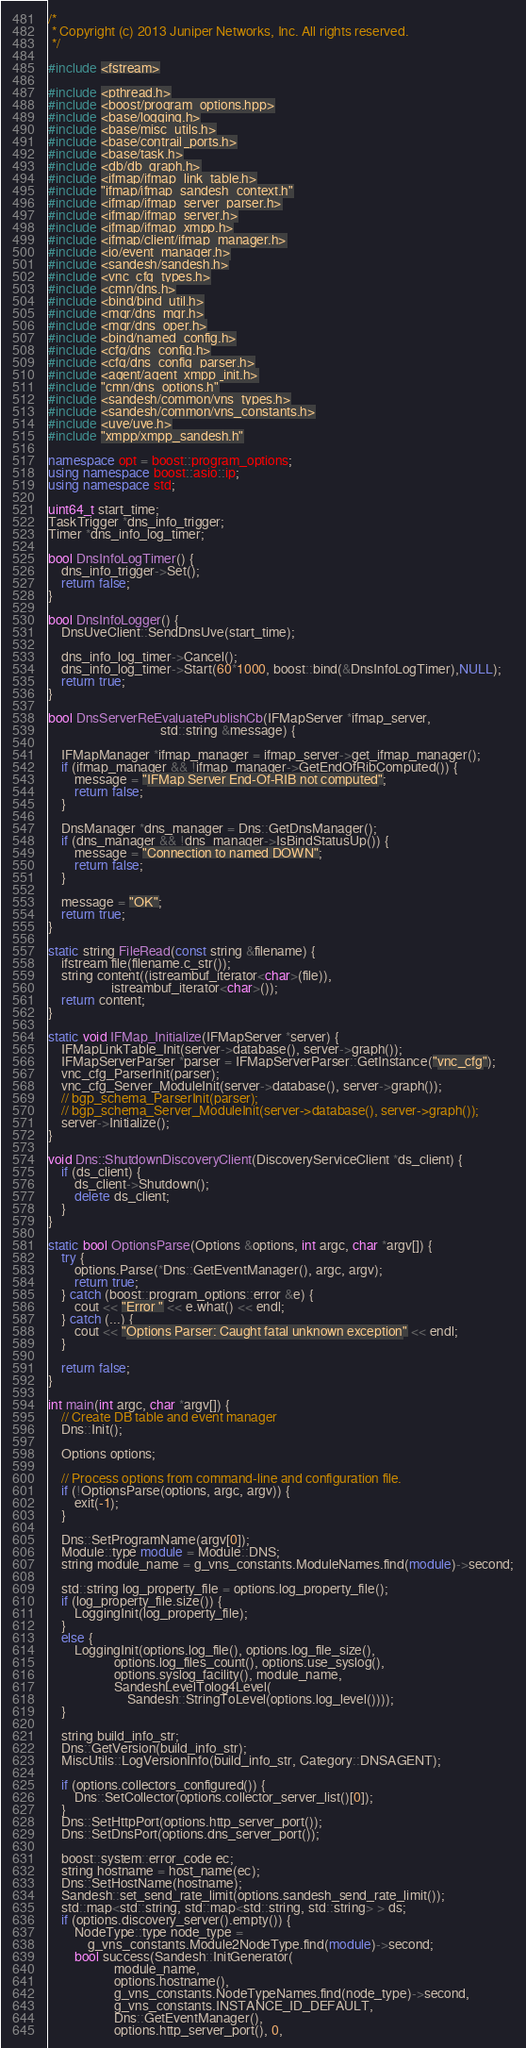Convert code to text. <code><loc_0><loc_0><loc_500><loc_500><_C++_>/*
 * Copyright (c) 2013 Juniper Networks, Inc. All rights reserved.
 */

#include <fstream>

#include <pthread.h>
#include <boost/program_options.hpp>
#include <base/logging.h>
#include <base/misc_utils.h>
#include <base/contrail_ports.h>
#include <base/task.h>
#include <db/db_graph.h>
#include <ifmap/ifmap_link_table.h>
#include "ifmap/ifmap_sandesh_context.h"
#include <ifmap/ifmap_server_parser.h>
#include <ifmap/ifmap_server.h>
#include <ifmap/ifmap_xmpp.h>
#include <ifmap/client/ifmap_manager.h>
#include <io/event_manager.h>
#include <sandesh/sandesh.h>
#include <vnc_cfg_types.h>
#include <cmn/dns.h>
#include <bind/bind_util.h>
#include <mgr/dns_mgr.h>
#include <mgr/dns_oper.h>
#include <bind/named_config.h>
#include <cfg/dns_config.h>
#include <cfg/dns_config_parser.h>
#include <agent/agent_xmpp_init.h>
#include "cmn/dns_options.h"
#include <sandesh/common/vns_types.h>
#include <sandesh/common/vns_constants.h>
#include <uve/uve.h>
#include "xmpp/xmpp_sandesh.h"

namespace opt = boost::program_options;
using namespace boost::asio::ip;
using namespace std;

uint64_t start_time;
TaskTrigger *dns_info_trigger;
Timer *dns_info_log_timer;

bool DnsInfoLogTimer() {
    dns_info_trigger->Set();
    return false;
}

bool DnsInfoLogger() {
    DnsUveClient::SendDnsUve(start_time);

    dns_info_log_timer->Cancel();
    dns_info_log_timer->Start(60*1000, boost::bind(&DnsInfoLogTimer),NULL);
    return true;
}

bool DnsServerReEvaluatePublishCb(IFMapServer *ifmap_server,
                                  std::string &message) {

    IFMapManager *ifmap_manager = ifmap_server->get_ifmap_manager();
    if (ifmap_manager && !ifmap_manager->GetEndOfRibComputed()) {
        message = "IFMap Server End-Of-RIB not computed";
        return false;
    }

    DnsManager *dns_manager = Dns::GetDnsManager();
    if (dns_manager && !dns_manager->IsBindStatusUp()) {
        message = "Connection to named DOWN";
        return false;
    }

    message = "OK";
    return true;
}

static string FileRead(const string &filename) {
    ifstream file(filename.c_str());
    string content((istreambuf_iterator<char>(file)),
                   istreambuf_iterator<char>());
    return content;
}

static void IFMap_Initialize(IFMapServer *server) {
    IFMapLinkTable_Init(server->database(), server->graph());
    IFMapServerParser *parser = IFMapServerParser::GetInstance("vnc_cfg");
    vnc_cfg_ParserInit(parser);
    vnc_cfg_Server_ModuleInit(server->database(), server->graph());
    // bgp_schema_ParserInit(parser);
    // bgp_schema_Server_ModuleInit(server->database(), server->graph());
    server->Initialize();
}

void Dns::ShutdownDiscoveryClient(DiscoveryServiceClient *ds_client) {
    if (ds_client) {
        ds_client->Shutdown();
        delete ds_client;
    }
}

static bool OptionsParse(Options &options, int argc, char *argv[]) {
    try {
        options.Parse(*Dns::GetEventManager(), argc, argv);
        return true;
    } catch (boost::program_options::error &e) {
        cout << "Error " << e.what() << endl;
    } catch (...) {
        cout << "Options Parser: Caught fatal unknown exception" << endl;
    }

    return false;
}

int main(int argc, char *argv[]) {
    // Create DB table and event manager
    Dns::Init();

    Options options;

    // Process options from command-line and configuration file.
    if (!OptionsParse(options, argc, argv)) {
        exit(-1);
    }

    Dns::SetProgramName(argv[0]);
    Module::type module = Module::DNS;
    string module_name = g_vns_constants.ModuleNames.find(module)->second;

    std::string log_property_file = options.log_property_file();
    if (log_property_file.size()) {
        LoggingInit(log_property_file);
    }
    else {
        LoggingInit(options.log_file(), options.log_file_size(),
                    options.log_files_count(), options.use_syslog(),
                    options.syslog_facility(), module_name,
                    SandeshLevelTolog4Level(
                        Sandesh::StringToLevel(options.log_level())));
    }

    string build_info_str;
    Dns::GetVersion(build_info_str);
    MiscUtils::LogVersionInfo(build_info_str, Category::DNSAGENT);

    if (options.collectors_configured()) {
        Dns::SetCollector(options.collector_server_list()[0]);
    }
    Dns::SetHttpPort(options.http_server_port());
    Dns::SetDnsPort(options.dns_server_port());

    boost::system::error_code ec;
    string hostname = host_name(ec);
    Dns::SetHostName(hostname);
    Sandesh::set_send_rate_limit(options.sandesh_send_rate_limit());
    std::map<std::string, std::map<std::string, std::string> > ds;
    if (options.discovery_server().empty()) {
        NodeType::type node_type =
            g_vns_constants.Module2NodeType.find(module)->second;
        bool success(Sandesh::InitGenerator(
                    module_name,
                    options.hostname(),
                    g_vns_constants.NodeTypeNames.find(node_type)->second,
                    g_vns_constants.INSTANCE_ID_DEFAULT,
                    Dns::GetEventManager(),
                    options.http_server_port(), 0,</code> 